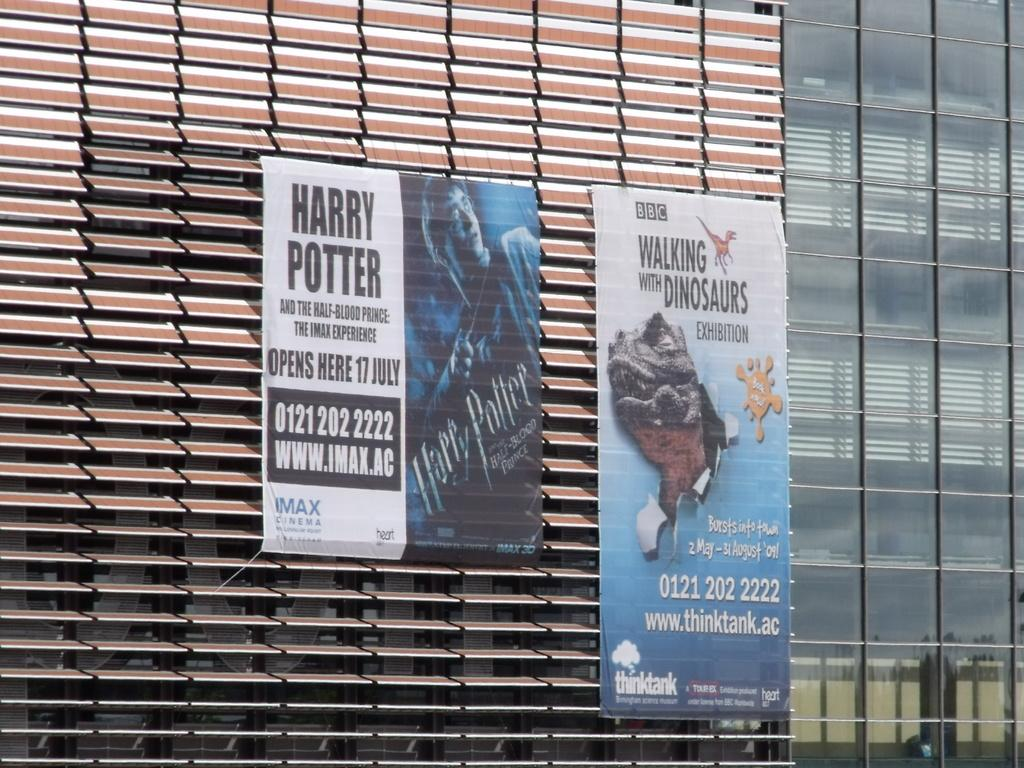<image>
Provide a brief description of the given image. A sign advertises that Harry Potter is opening there in July. 